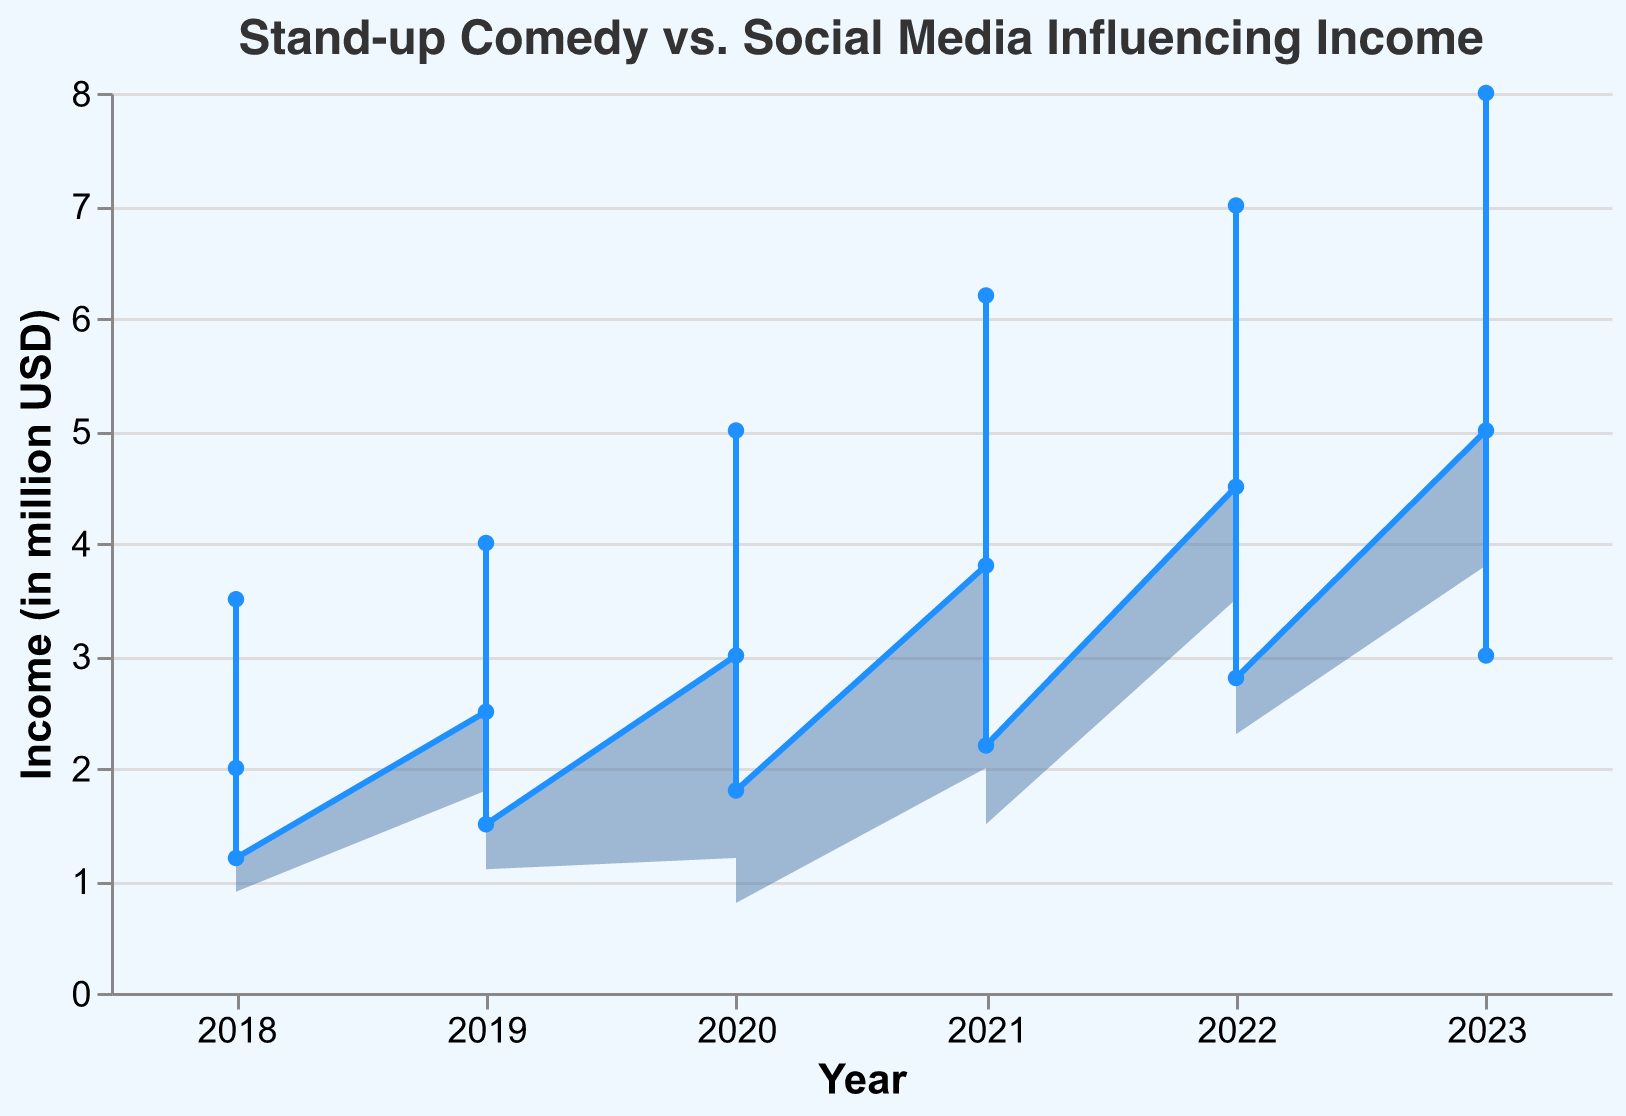What is the title of the chart? The chart's title is displayed at the top of the figure.
Answer: Stand-up Comedy vs. Social Media Influencing Income What is the color used for the line and points in the chart? The line and points are colored the same, and their color should be easily seen in the chart.
Answer: Blue What are the years displayed along the x-axis? The x-axis represents time in years, and these years are labeled at the bottom of the chart.
Answer: 2018, 2019, 2020, 2021, 2022, 2023 How does the income from social media influencing in 2023 compare to 2022? Look at the height of the area under "Social Media Influencing Income" for the years 2022 and 2023.
Answer: It increased What trend can be observed in stand-up comedy income over the past 5 years? By reviewing the series of data points for "Stand-up Comedy Income" from 2018 to 2023, you can detect a trend.
Answer: Increasing What is the peak income year for stand-up comedy? Identify the year where the 'Stand-up Comedy Income' area is at its highest point.
Answer: 2023 Was there any year where income from social media influencing declined compared to the previous year? Check the height of the social media influencing income area for any dips compared to the previous year.
Answer: No What's the maximum income recorded for social media influencing in the past five years? Find the data point where the area for social media influencing income reaches its highest peak.
Answer: 8.0 million USD What is the difference in income between social media influencing and stand-up comedy in 2021? Compare the heights of the areas for both incomes in 2021 to find the difference.
Answer: 3.4 million USD What is the average stand-up comedy income across the years presented? Sum up the stand-up comedy incomes from all the years and divide by the number of years.
Answer: 2.48 million USD 